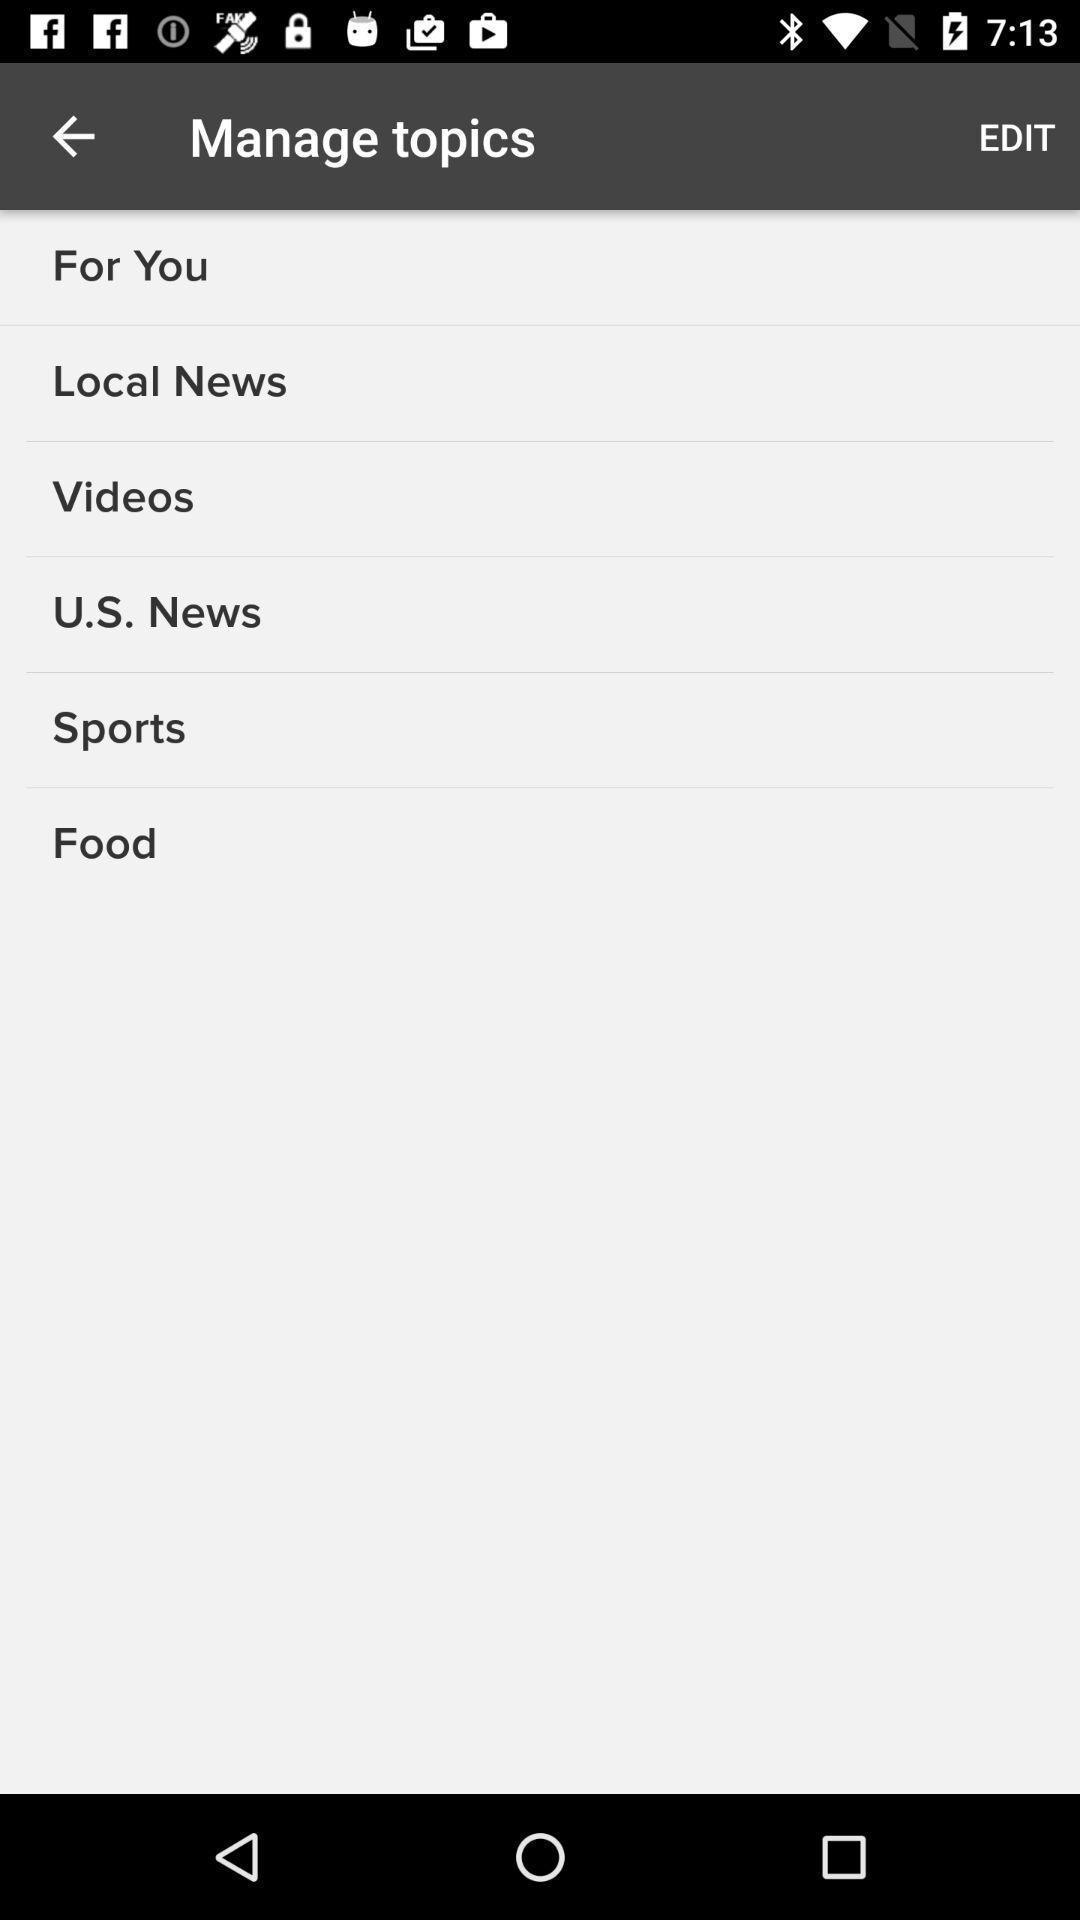Describe the content in this image. Page showing multiple options. 